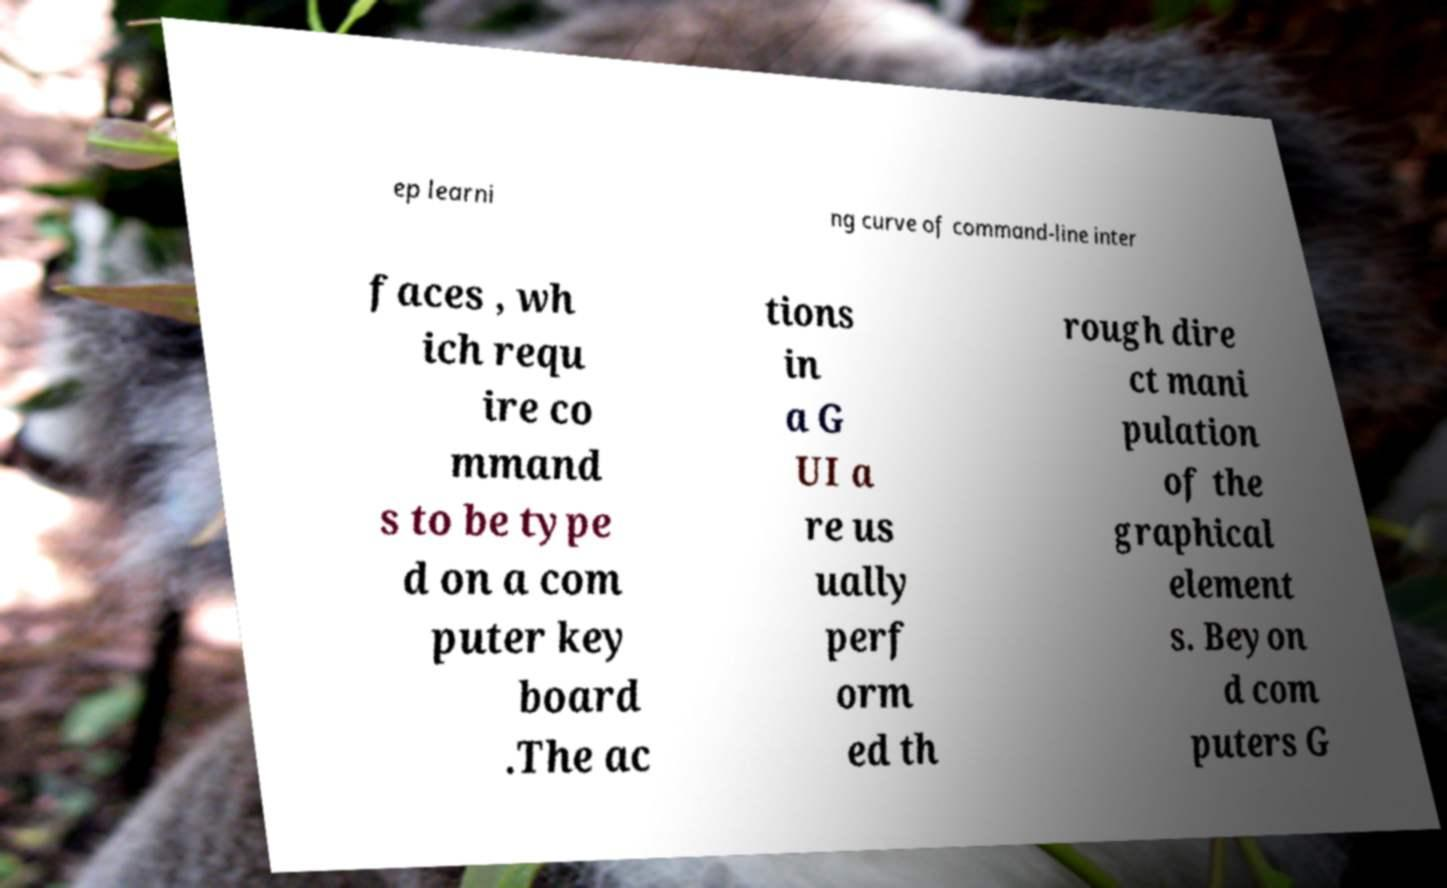Can you read and provide the text displayed in the image?This photo seems to have some interesting text. Can you extract and type it out for me? ep learni ng curve of command-line inter faces , wh ich requ ire co mmand s to be type d on a com puter key board .The ac tions in a G UI a re us ually perf orm ed th rough dire ct mani pulation of the graphical element s. Beyon d com puters G 